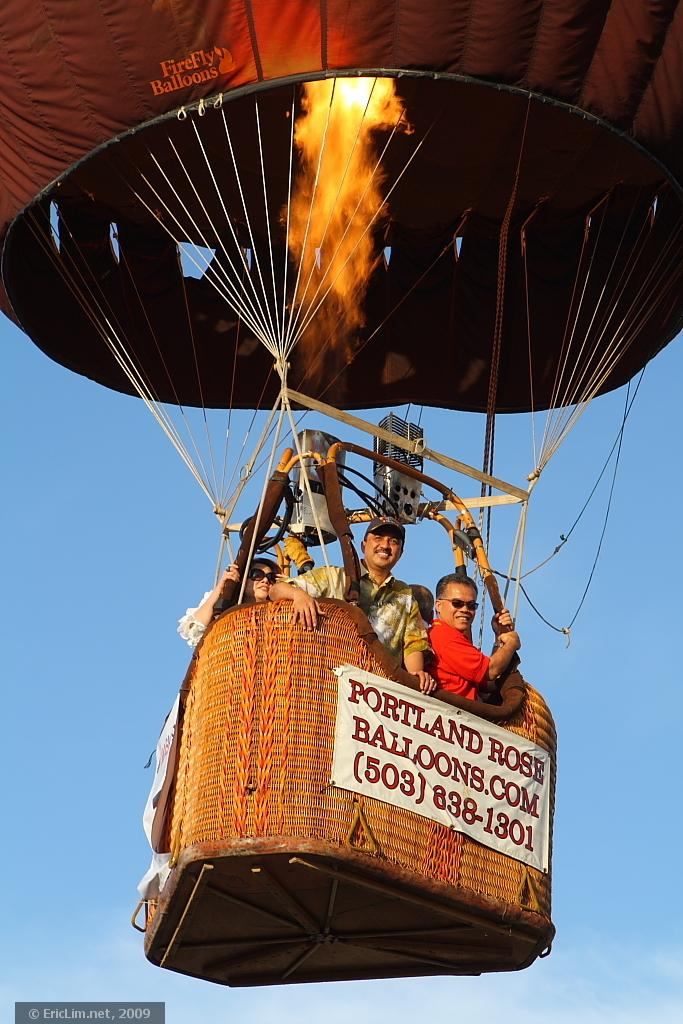<image>
Provide a brief description of the given image. A hot air balloon with a Portland Balloon.com sign floats in a blue sky. 